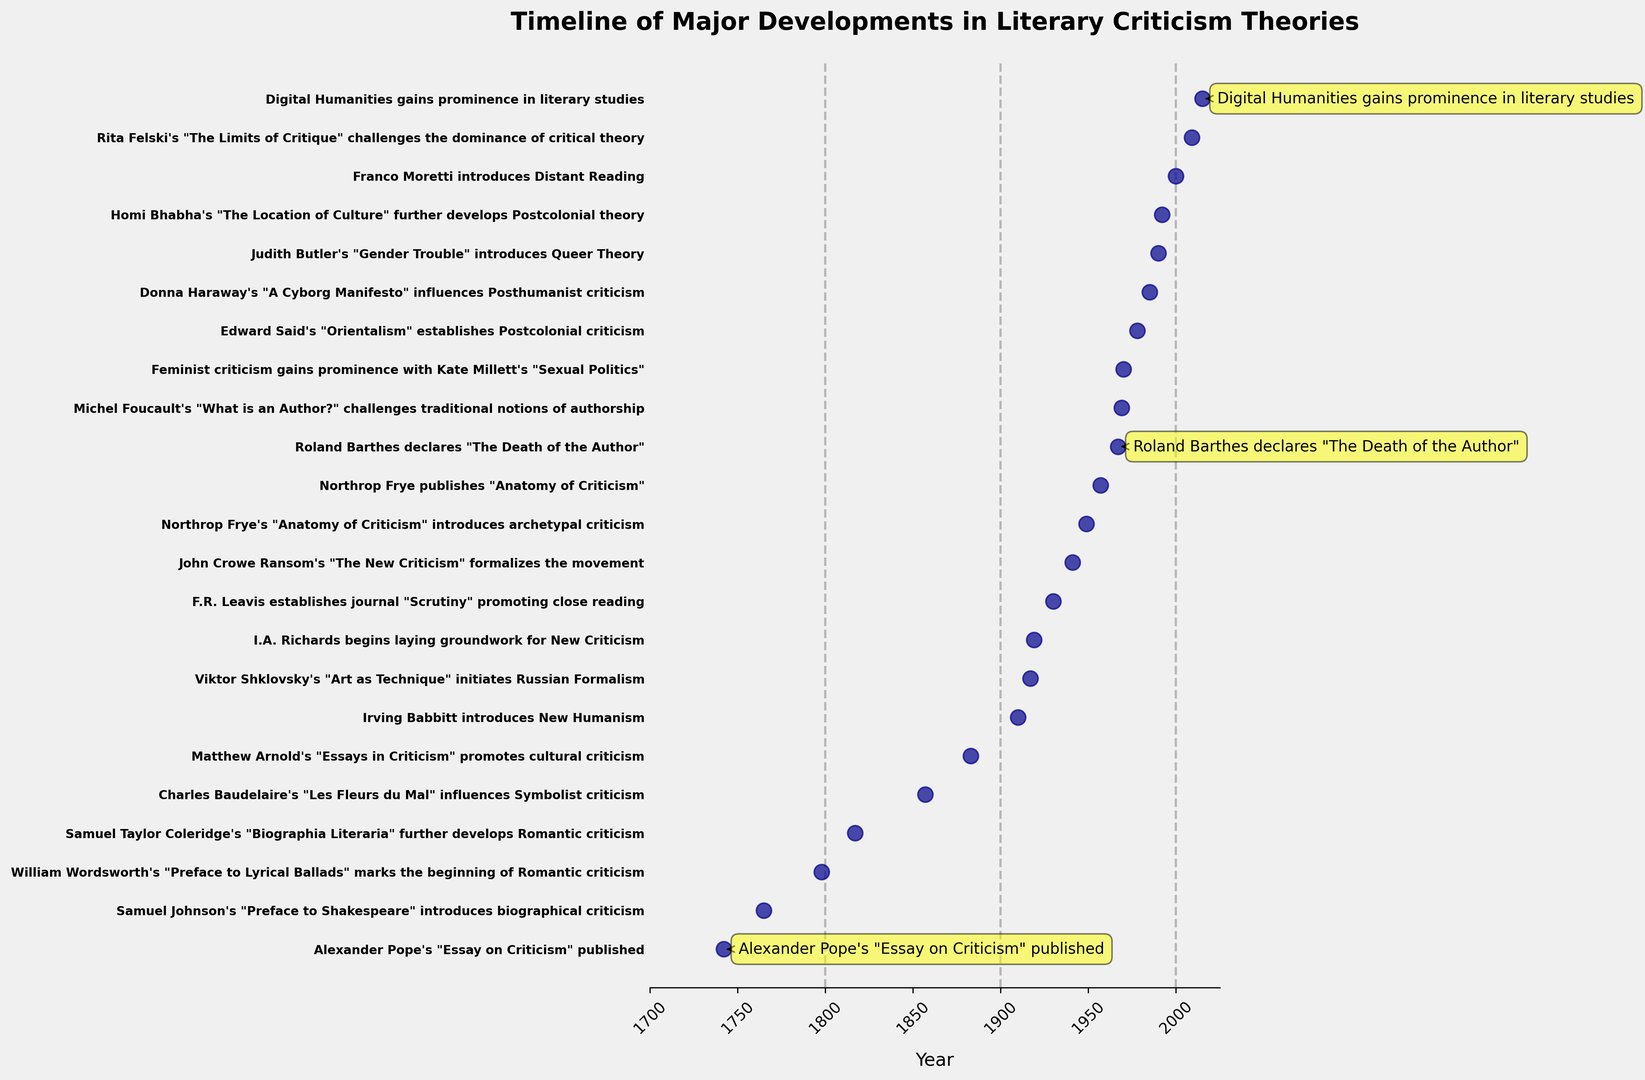Which event marks the beginning of Romantic criticism? The figure lists events chronologically, and the event marking the beginning of Romantic criticism is William Wordsworth's "Preface to Lyrical Ballads."
Answer: William Wordsworth's "Preface to Lyrical Ballads" Which key event is annotated with a yellow highlight in the year 1967? The figure annotates key events with yellow highlights, and in the year 1967, the highlighted event is Roland Barthes declaring "The Death of the Author."
Answer: Roland Barthes declares "The Death of the Author" Which two events are the furthest apart in time in the given timeline? The earliest event is Alexander Pope's "Essay on Criticism" published in 1742, and the latest event is Digital Humanities gaining prominence in literary studies in 2015. Calculating the difference in years: 2015 - 1742 = 273 years.
Answer: Alexander Pope's "Essay on Criticism" and Digital Humanities gaining prominence in literary studies Between 1940 and 1970, how many major events in literary criticism theories took place? The plot highlights events between specific years. Between 1940 and 1970, the events are John Crowe Ransom's "The New Criticism" (1941), Northrop Frye's "Anatomy of Criticism" (1949 and 1957), Roland Barthes declares "The Death of the Author" (1967), and Michel Foucault's "What is an Author?" (1969). Counting these, we have 5 events.
Answer: 5 Which century has more annotated events: the 19th or the 20th century? The plot annotates specific events in each century. The 19th century (1800s) includes: William Wordsworth (1798, slightly outside but close), Samuel Taylor Coleridge (1817), Charles Baudelaire (1857), and Matthew Arnold (1883) making 4 events. The 20th century (1900s) includes: Viktor Shklovsky (1917), I.A. Richards (1919), F.R. Leavis (1930), John Crowe Ransom (1941), Northrop Frye (1949, 1957), Roland Barthes (1967), Michel Foucault (1969), and Edward Said (1978), making 8 events. So, the 20th century has more annotated events.
Answer: 20th century Is biographical criticism introduced before or after Romantic criticism begins? The figure shows Samuel Johnson's "Preface to Shakespeare" introducing biographical criticism in 1765, and William Wordsworth's "Preface to Lyrical Ballads" marking the beginning of Romantic criticism in 1798. Therefore, biographical criticism is introduced before Romantic criticism begins.
Answer: Before Which event influenced Symbolist criticism, and in what year was it published? Checking each event on the timeline, the one that influenced Symbolist criticism is Charles Baudelaire's "Les Fleurs du Mal," published in 1857.
Answer: Charles Baudelaire's "Les Fleurs du Mal", 1857 How many years after the establishment of Postcolonial criticism did Feminist criticism gain prominence? Edward Said's "Orientalism" establishing Postcolonial criticism is in 1978, and Kate Millett's "Sexual Politics" gaining prominence for Feminist criticism is in 1970. However, since 1970 precedes 1978, this question might be interpreted the other way: how many years before Postcolonial criticism did Feminist criticism gain prominence. Therefore, calculating 1978 - 1970: 8 years.
Answer: 8 years before 